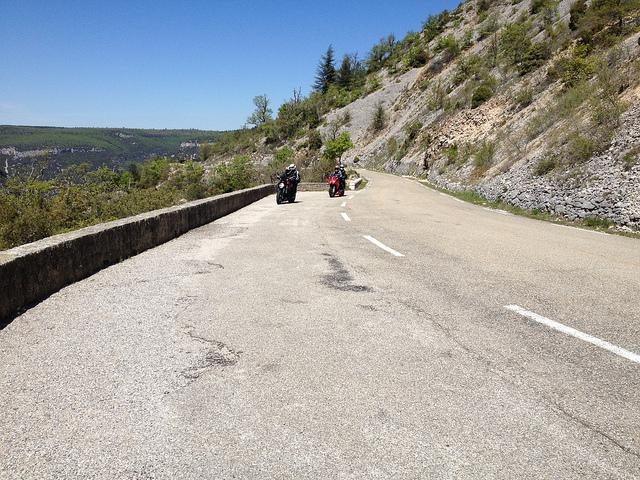Is the road stained?
Give a very brief answer. Yes. What vehicle is here?
Keep it brief. Motorcycle. How many stripes are visible on the road?
Write a very short answer. 5. What color are the stripes?
Keep it brief. White. 